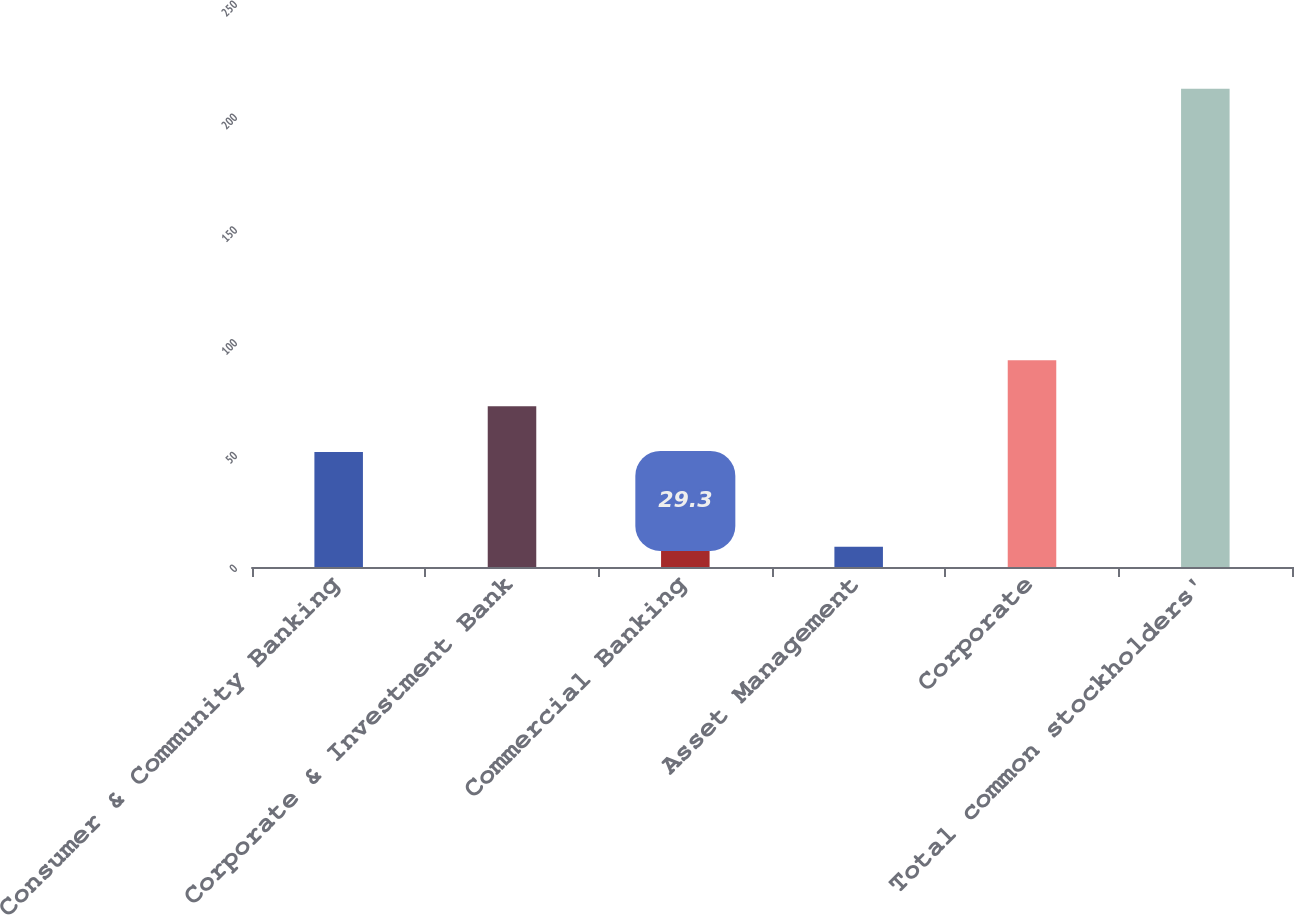Convert chart. <chart><loc_0><loc_0><loc_500><loc_500><bar_chart><fcel>Consumer & Community Banking<fcel>Corporate & Investment Bank<fcel>Commercial Banking<fcel>Asset Management<fcel>Corporate<fcel>Total common stockholders'<nl><fcel>51<fcel>71.3<fcel>29.3<fcel>9<fcel>91.6<fcel>212<nl></chart> 